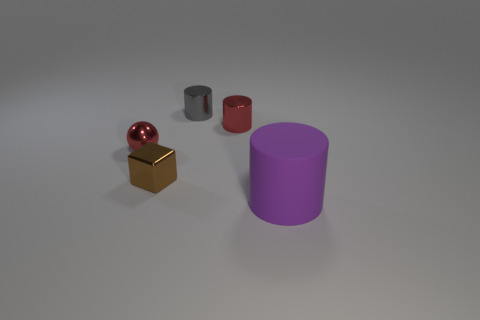Add 4 metallic cylinders. How many objects exist? 9 Subtract all metal cylinders. How many cylinders are left? 1 Subtract all gray cylinders. How many cylinders are left? 2 Subtract all cubes. How many objects are left? 4 Subtract all green cylinders. Subtract all gray blocks. How many cylinders are left? 3 Subtract all gray balls. How many red cylinders are left? 1 Subtract all metallic objects. Subtract all small gray cylinders. How many objects are left? 0 Add 1 tiny brown metal blocks. How many tiny brown metal blocks are left? 2 Add 3 small purple metallic cylinders. How many small purple metallic cylinders exist? 3 Subtract 0 purple spheres. How many objects are left? 5 